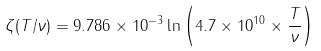<formula> <loc_0><loc_0><loc_500><loc_500>\zeta ( T / \nu ) = 9 . 7 8 6 \times 1 0 ^ { - 3 } \ln \left ( 4 . 7 \times 1 0 ^ { 1 0 } \times \frac { T } { \nu } \right )</formula> 